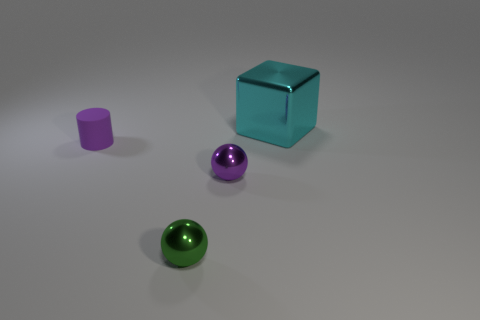How many large things are matte things or cyan cubes?
Make the answer very short. 1. Do the purple object that is to the left of the green metallic sphere and the small green thing have the same material?
Your answer should be compact. No. What is the color of the metal thing that is behind the small cylinder?
Keep it short and to the point. Cyan. Are there any gray metal balls of the same size as the purple rubber cylinder?
Your answer should be very brief. No. There is a purple ball that is the same size as the matte cylinder; what material is it?
Your response must be concise. Metal. There is a cyan object; is its size the same as the purple thing that is on the right side of the cylinder?
Offer a very short reply. No. What is the material of the sphere that is behind the green metal ball?
Ensure brevity in your answer.  Metal. Are there an equal number of big cubes right of the large cyan block and tiny cylinders?
Your response must be concise. No. Does the cyan metal cube have the same size as the purple metal object?
Make the answer very short. No. Are there any cyan things that are to the left of the small shiny ball that is to the left of the metal sphere that is behind the green metal object?
Make the answer very short. No. 